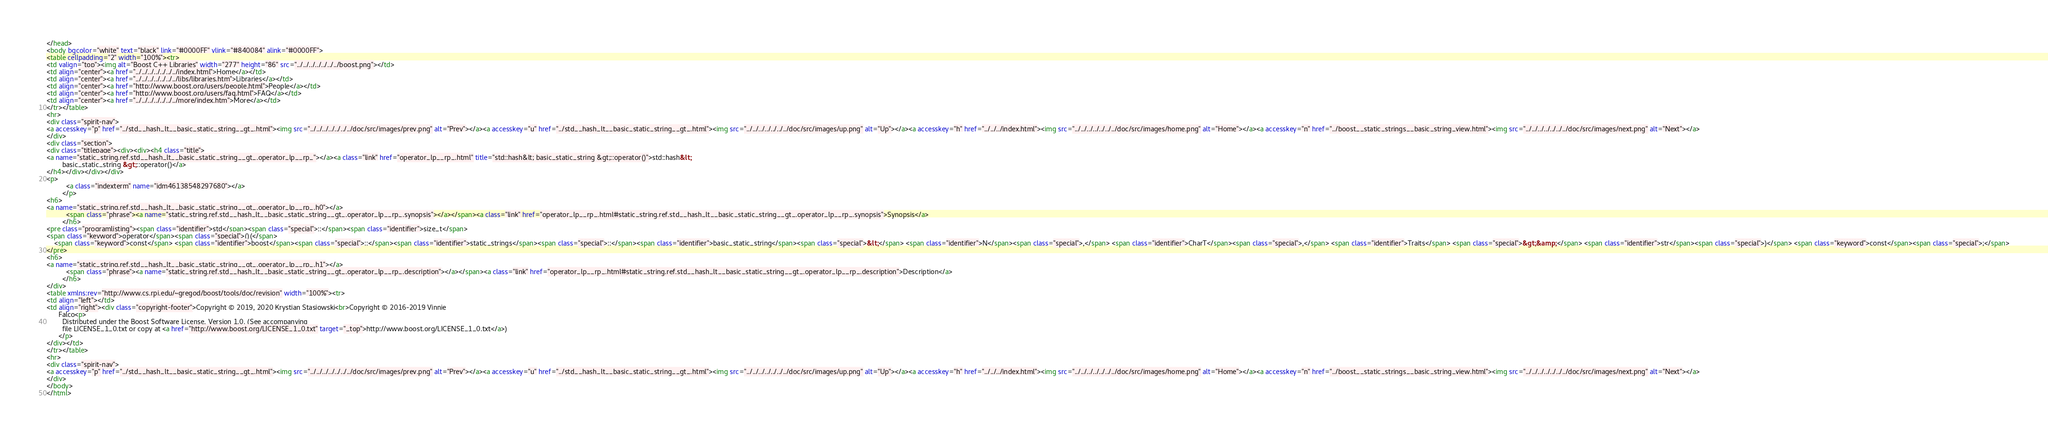<code> <loc_0><loc_0><loc_500><loc_500><_HTML_></head>
<body bgcolor="white" text="black" link="#0000FF" vlink="#840084" alink="#0000FF">
<table cellpadding="2" width="100%"><tr>
<td valign="top"><img alt="Boost C++ Libraries" width="277" height="86" src="../../../../../../../boost.png"></td>
<td align="center"><a href="../../../../../../../index.html">Home</a></td>
<td align="center"><a href="../../../../../../../libs/libraries.htm">Libraries</a></td>
<td align="center"><a href="http://www.boost.org/users/people.html">People</a></td>
<td align="center"><a href="http://www.boost.org/users/faq.html">FAQ</a></td>
<td align="center"><a href="../../../../../../../more/index.htm">More</a></td>
</tr></table>
<hr>
<div class="spirit-nav">
<a accesskey="p" href="../std__hash_lt__basic_static_string__gt_.html"><img src="../../../../../../../doc/src/images/prev.png" alt="Prev"></a><a accesskey="u" href="../std__hash_lt__basic_static_string__gt_.html"><img src="../../../../../../../doc/src/images/up.png" alt="Up"></a><a accesskey="h" href="../../../index.html"><img src="../../../../../../../doc/src/images/home.png" alt="Home"></a><a accesskey="n" href="../boost__static_strings__basic_string_view.html"><img src="../../../../../../../doc/src/images/next.png" alt="Next"></a>
</div>
<div class="section">
<div class="titlepage"><div><div><h4 class="title">
<a name="static_string.ref.std__hash_lt__basic_static_string__gt_.operator_lp__rp_"></a><a class="link" href="operator_lp__rp_.html" title="std::hash&lt; basic_static_string &gt;::operator()">std::hash&lt;
        basic_static_string &gt;::operator()</a>
</h4></div></div></div>
<p>
          <a class="indexterm" name="idm46138548297680"></a>
        </p>
<h6>
<a name="static_string.ref.std__hash_lt__basic_static_string__gt_.operator_lp__rp_.h0"></a>
          <span class="phrase"><a name="static_string.ref.std__hash_lt__basic_static_string__gt_.operator_lp__rp_.synopsis"></a></span><a class="link" href="operator_lp__rp_.html#static_string.ref.std__hash_lt__basic_static_string__gt_.operator_lp__rp_.synopsis">Synopsis</a>
        </h6>
<pre class="programlisting"><span class="identifier">std</span><span class="special">::</span><span class="identifier">size_t</span>
<span class="keyword">operator</span><span class="special">()(</span>
    <span class="keyword">const</span> <span class="identifier">boost</span><span class="special">::</span><span class="identifier">static_strings</span><span class="special">::</span><span class="identifier">basic_static_string</span><span class="special">&lt;</span> <span class="identifier">N</span><span class="special">,</span> <span class="identifier">CharT</span><span class="special">,</span> <span class="identifier">Traits</span> <span class="special">&gt;&amp;</span> <span class="identifier">str</span><span class="special">)</span> <span class="keyword">const</span><span class="special">;</span>
</pre>
<h6>
<a name="static_string.ref.std__hash_lt__basic_static_string__gt_.operator_lp__rp_.h1"></a>
          <span class="phrase"><a name="static_string.ref.std__hash_lt__basic_static_string__gt_.operator_lp__rp_.description"></a></span><a class="link" href="operator_lp__rp_.html#static_string.ref.std__hash_lt__basic_static_string__gt_.operator_lp__rp_.description">Description</a>
        </h6>
</div>
<table xmlns:rev="http://www.cs.rpi.edu/~gregod/boost/tools/doc/revision" width="100%"><tr>
<td align="left"></td>
<td align="right"><div class="copyright-footer">Copyright © 2019, 2020 Krystian Stasiowski<br>Copyright © 2016-2019 Vinnie
      Falco<p>
        Distributed under the Boost Software License, Version 1.0. (See accompanying
        file LICENSE_1_0.txt or copy at <a href="http://www.boost.org/LICENSE_1_0.txt" target="_top">http://www.boost.org/LICENSE_1_0.txt</a>)
      </p>
</div></td>
</tr></table>
<hr>
<div class="spirit-nav">
<a accesskey="p" href="../std__hash_lt__basic_static_string__gt_.html"><img src="../../../../../../../doc/src/images/prev.png" alt="Prev"></a><a accesskey="u" href="../std__hash_lt__basic_static_string__gt_.html"><img src="../../../../../../../doc/src/images/up.png" alt="Up"></a><a accesskey="h" href="../../../index.html"><img src="../../../../../../../doc/src/images/home.png" alt="Home"></a><a accesskey="n" href="../boost__static_strings__basic_string_view.html"><img src="../../../../../../../doc/src/images/next.png" alt="Next"></a>
</div>
</body>
</html>
</code> 